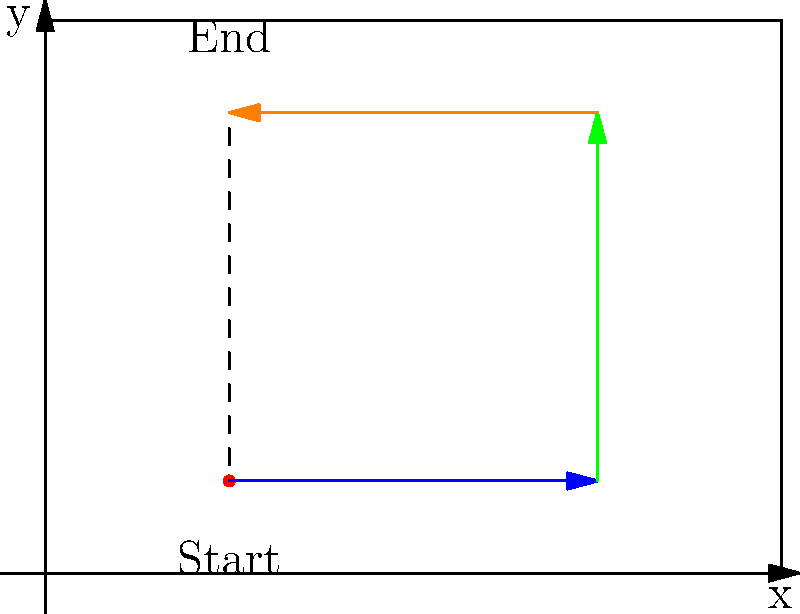A robot starts at the point (2,1) in a rectangular living room. It moves 4 units to the right, then 4 units up, and finally 4 units to the left. What are the coordinates of the robot's final position? Let's follow the robot's path step by step:

1. The robot starts at the point (2,1).

2. It moves 4 units to the right:
   - This increases the x-coordinate by 4
   - New position: (2+4, 1) = (6,1)

3. Then it moves 4 units up:
   - This increases the y-coordinate by 4
   - New position: (6, 1+4) = (6,5)

4. Finally, it moves 4 units to the left:
   - This decreases the x-coordinate by 4
   - Final position: (6-4, 5) = (2,5)

Therefore, the robot's final coordinates are (2,5).
Answer: (2,5) 